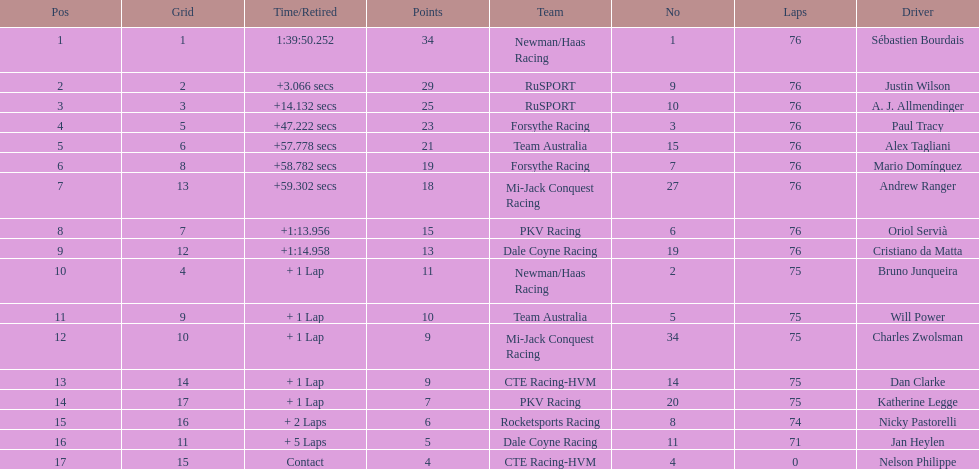What was the total points that canada earned together? 62. 